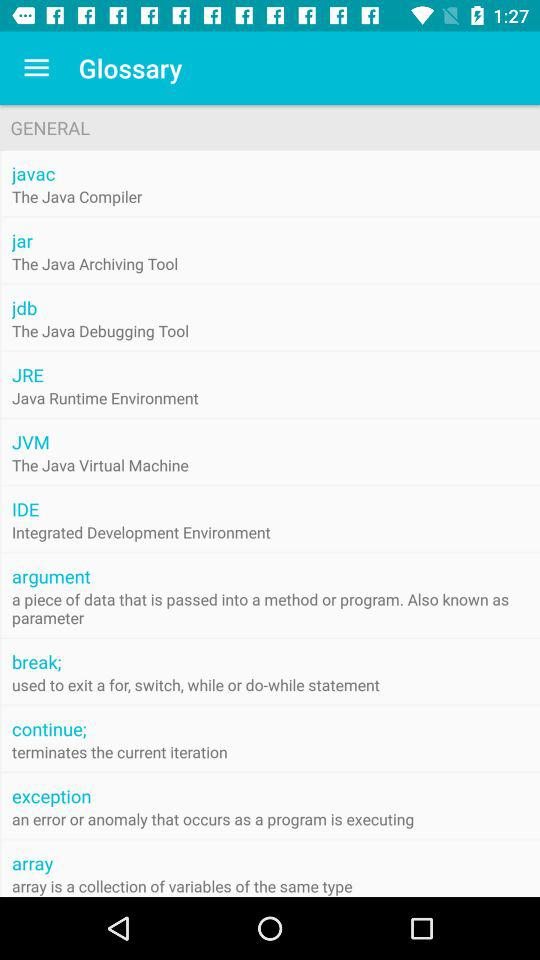What is an argument? An argument is a piece of data that is passed into a method or program. 